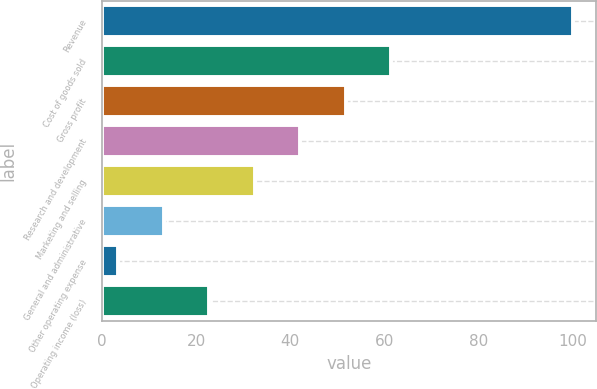Convert chart to OTSL. <chart><loc_0><loc_0><loc_500><loc_500><bar_chart><fcel>Revenue<fcel>Cost of goods sold<fcel>Gross profit<fcel>Research and development<fcel>Marketing and selling<fcel>General and administrative<fcel>Other operating expense<fcel>Operating income (loss)<nl><fcel>100<fcel>61.4<fcel>51.75<fcel>42.1<fcel>32.45<fcel>13.15<fcel>3.5<fcel>22.8<nl></chart> 